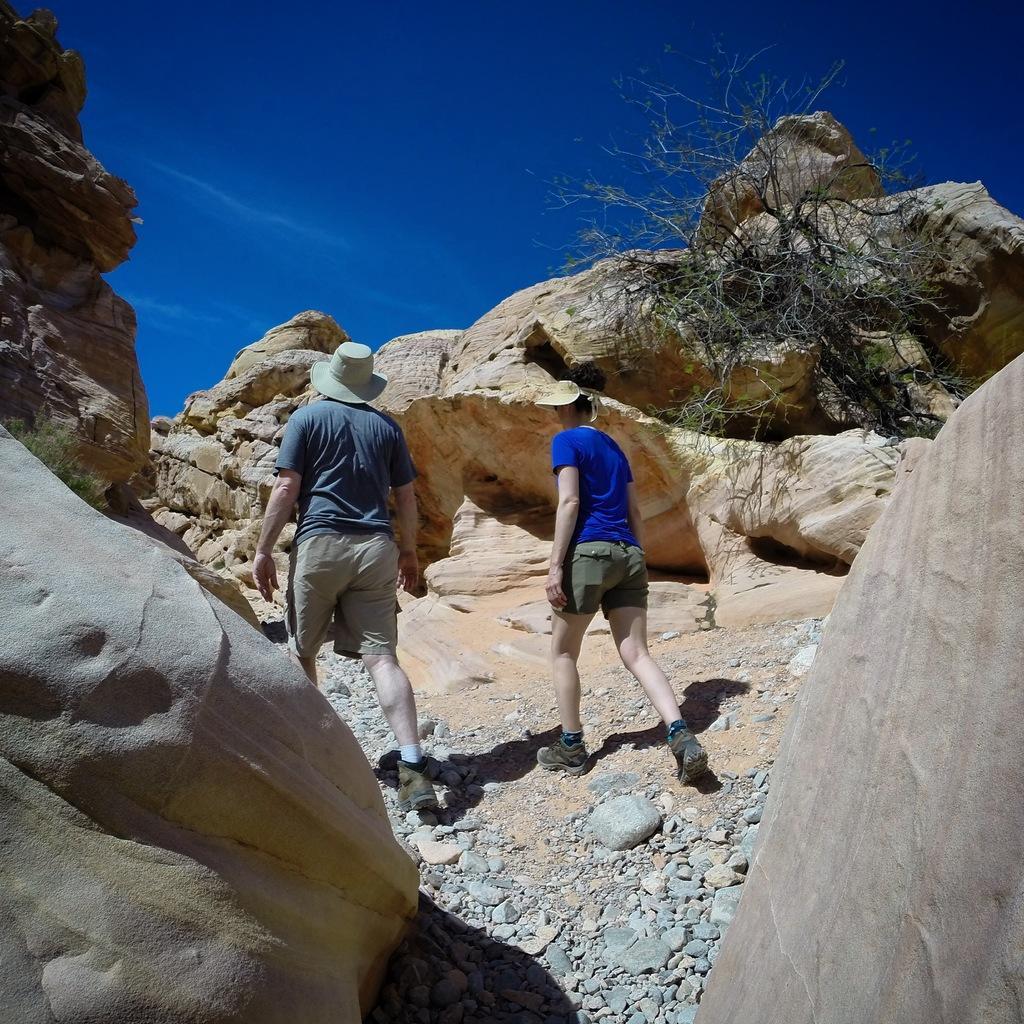Can you describe this image briefly? In the middle of the image two persons are walking and there are some stones and hills and trees. At the top of the image there are some clouds and sky. 